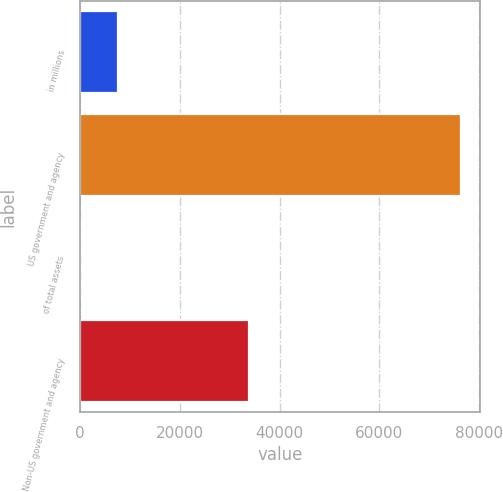Convert chart. <chart><loc_0><loc_0><loc_500><loc_500><bar_chart><fcel>in millions<fcel>US government and agency<fcel>of total assets<fcel>Non-US government and agency<nl><fcel>7649.27<fcel>76418<fcel>8.3<fcel>33956<nl></chart> 